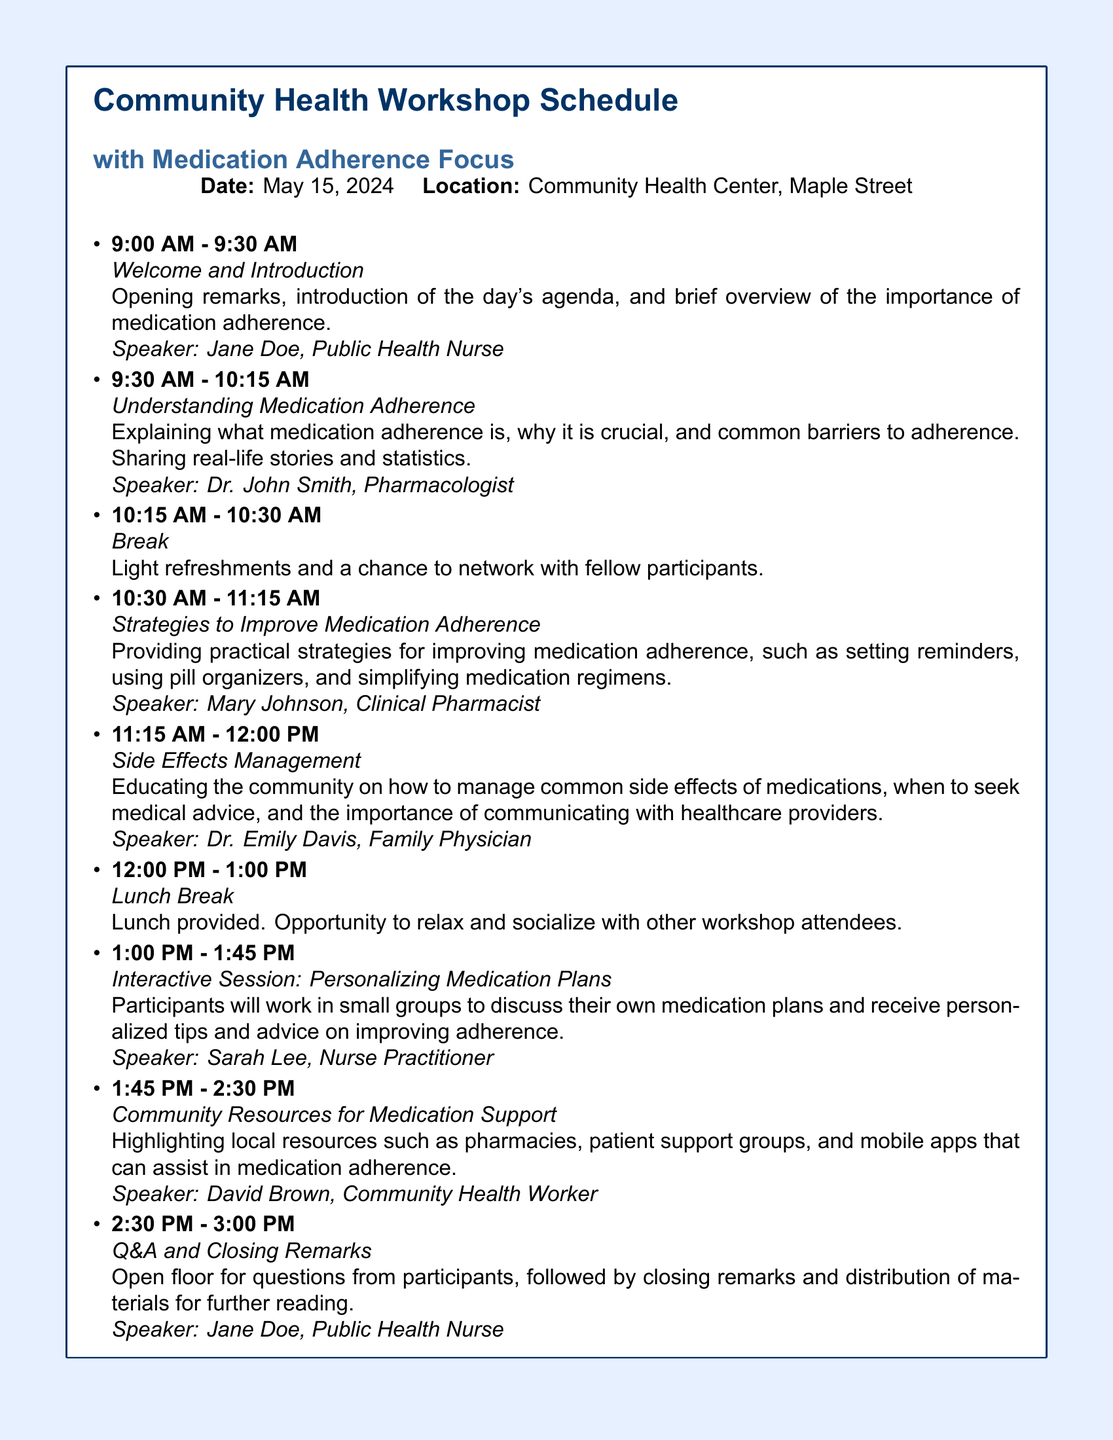What is the date of the workshop? The date of the workshop is explicitly stated in the document as May 15, 2024.
Answer: May 15, 2024 Who is the speaker for the "Understanding Medication Adherence" session? The speaker's name for this session is provided in the document as Dr. John Smith.
Answer: Dr. John Smith What time does the "Side Effects Management" session start? The document lists the start time for this session as 11:15 AM.
Answer: 11:15 AM How long is the lunch break? The duration of the lunch break is indicated in the document as one hour.
Answer: 1 hour What is the topic of the session at 10:30 AM? The document outlines this session's topic as "Strategies to Improve Medication Adherence."
Answer: Strategies to Improve Medication Adherence Who will facilitate the "Interactive Session: Personalizing Medication Plans"? This information is provided as Sarah Lee in the document.
Answer: Sarah Lee What type of resources will be highlighted in the "Community Resources for Medication Support" session? The document states that local resources such as pharmacies, support groups, and mobile apps will be discussed.
Answer: Local resources What is the primary focus of the workshop? The document indicates that the main focus of the workshop is medication adherence.
Answer: Medication adherence What will happen during the Q&A and Closing Remarks session? The document outlines that there will be an open floor for questions followed by closing remarks.
Answer: Questions and closing remarks 